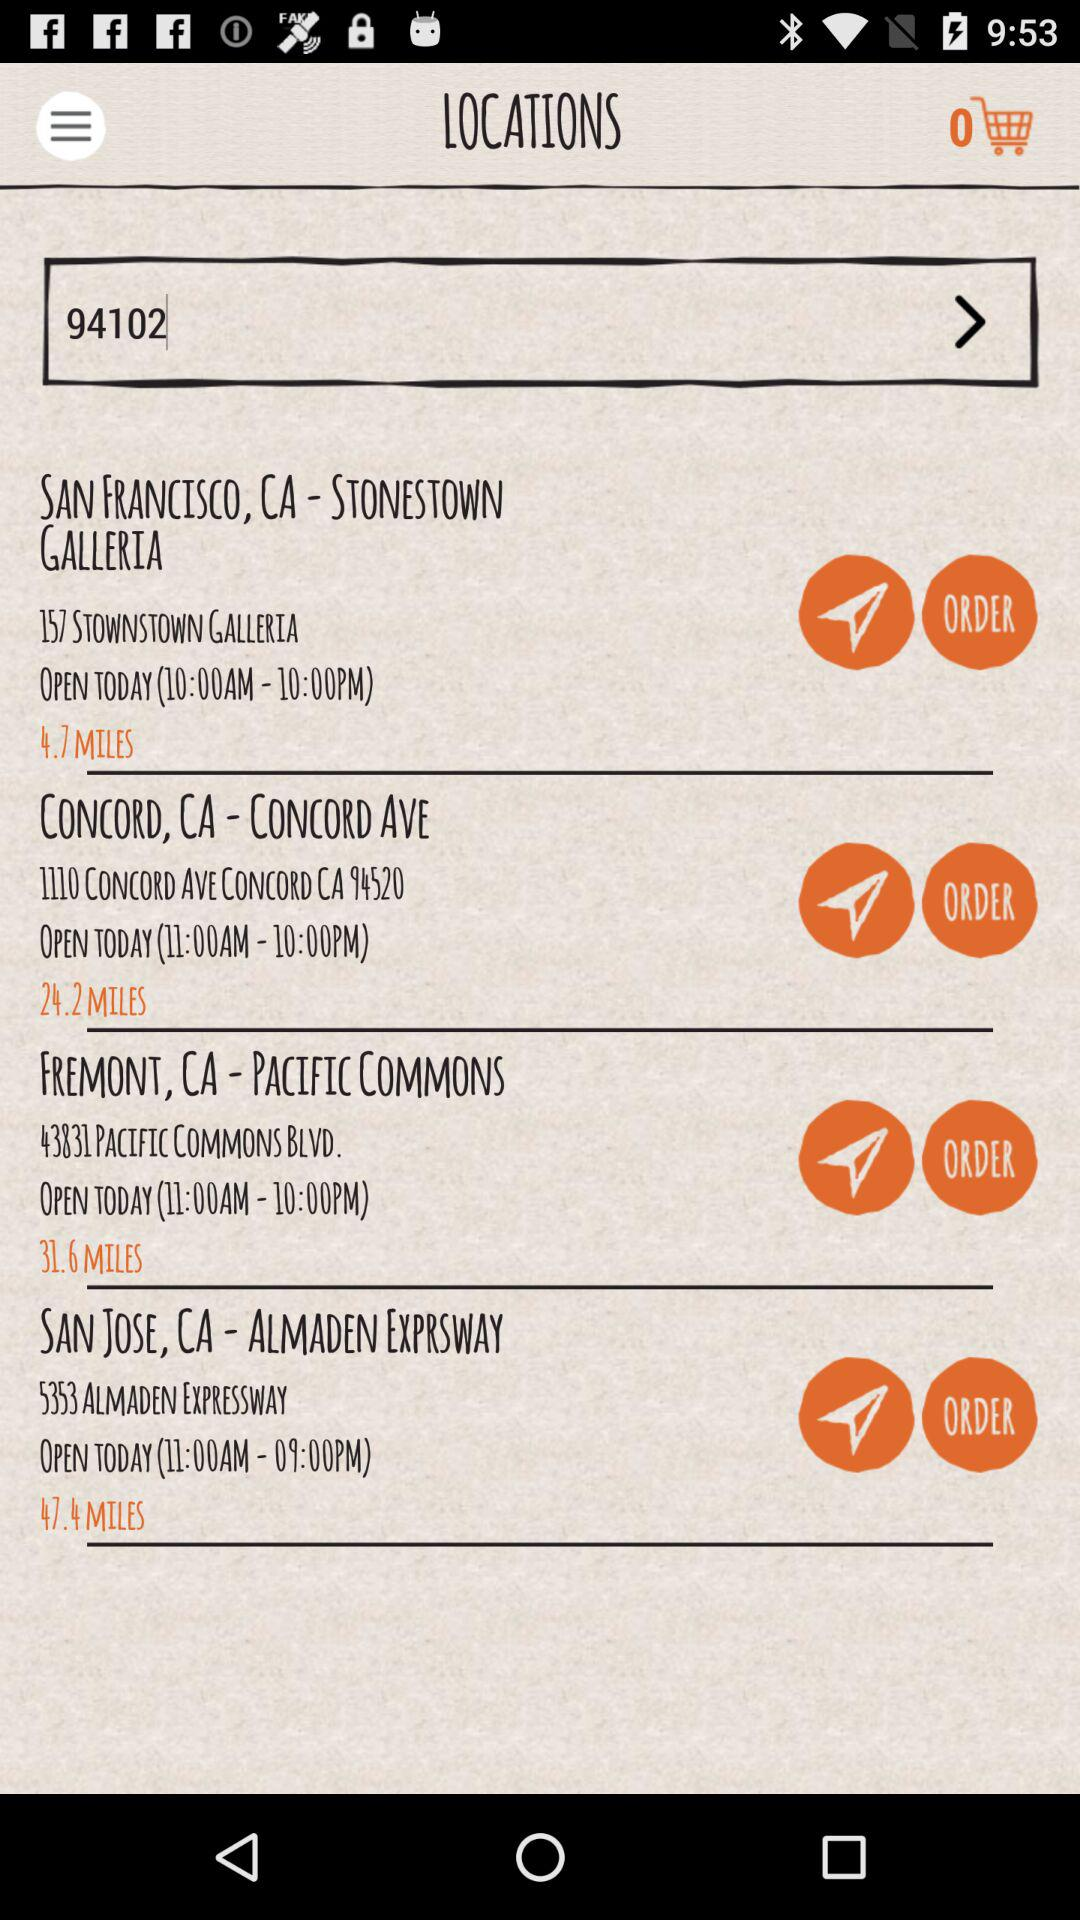What is the opening time for "SAN FRANCISCO, CA - STONESTOWN GALLERIA"? The opening time for "SAN FRANCISCO, CA - STONESTOWN GALLERIA" is 10:00 a.m. 